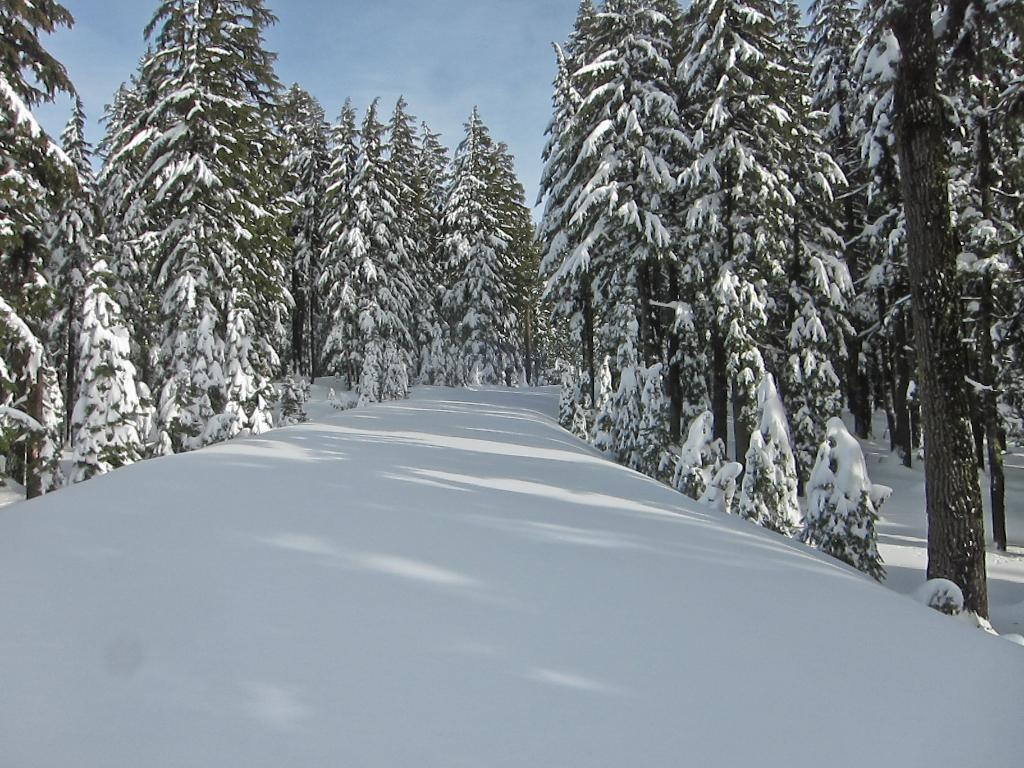Describe this image in one or two sentences. This picture is clicked outside and we can see there is a lot of snow. In the center we can see the trees and the plants. In the background we can see the sky. 